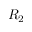<formula> <loc_0><loc_0><loc_500><loc_500>R _ { 2 }</formula> 